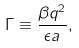<formula> <loc_0><loc_0><loc_500><loc_500>\Gamma \equiv \frac { \beta q ^ { 2 } } { \epsilon a } ,</formula> 